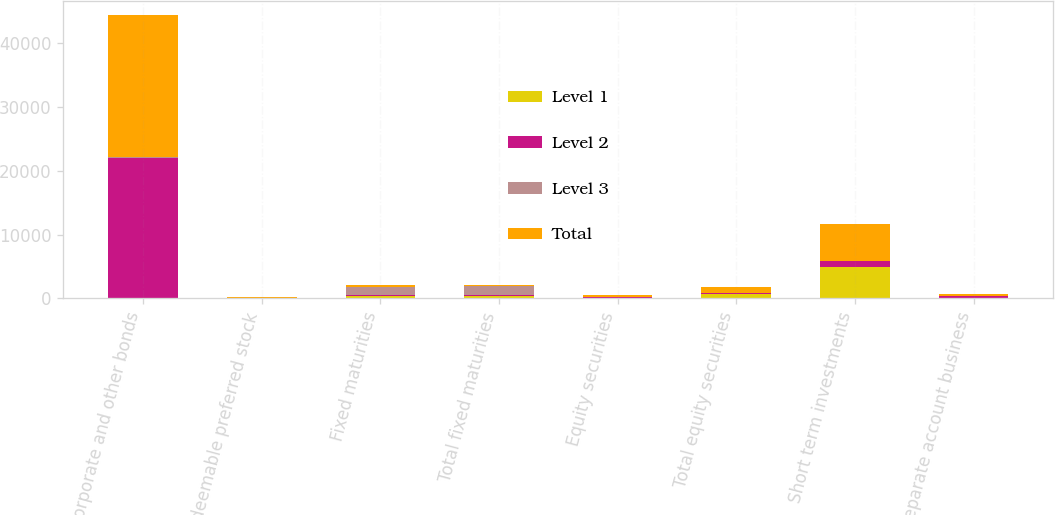<chart> <loc_0><loc_0><loc_500><loc_500><stacked_bar_chart><ecel><fcel>Corporate and other bonds<fcel>Redeemable preferred stock<fcel>Fixed maturities<fcel>Total fixed maturities<fcel>Equity securities<fcel>Total equity securities<fcel>Short term investments<fcel>Separate account business<nl><fcel>Level 1<fcel>6<fcel>40<fcel>344<fcel>344<fcel>117<fcel>759<fcel>4990<fcel>4<nl><fcel>Level 2<fcel>21982<fcel>59<fcel>234<fcel>234<fcel>98<fcel>98<fcel>799<fcel>306<nl><fcel>Level 3<fcel>219<fcel>26<fcel>1251<fcel>1340<fcel>34<fcel>41<fcel>6<fcel>2<nl><fcel>Total<fcel>22207<fcel>125<fcel>234<fcel>234<fcel>249<fcel>898<fcel>5795<fcel>312<nl></chart> 